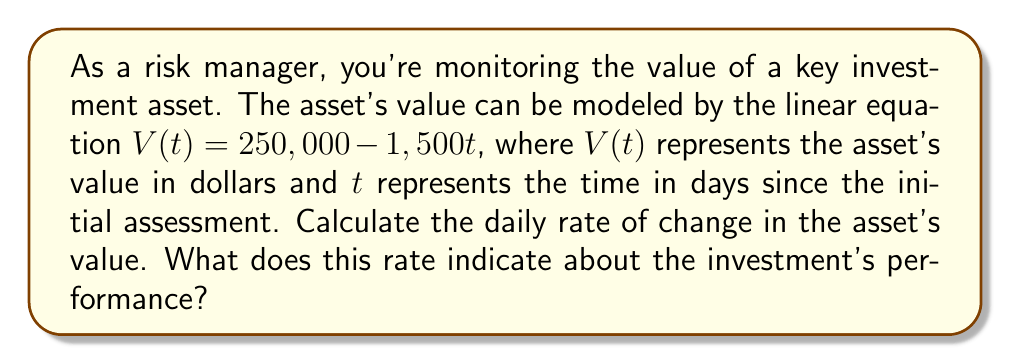Can you answer this question? To solve this problem, we need to understand the concept of rate of change in a linear equation.

1) The general form of a linear equation is $y = mx + b$, where $m$ represents the slope or rate of change.

2) In our case, we have $V(t) = 250,000 - 1,500t$

3) Comparing this to the general form, we can see that:
   $m = -1,500$
   $b = 250,000$

4) The slope $m$ represents the rate of change of $V$ with respect to $t$. In this context, it's the daily rate of change in the asset's value.

5) The negative sign indicates that the value is decreasing over time.

6) Therefore, the daily rate of change is -$1,500 per day.

This rate indicates that the investment is losing value at a constant rate of $1,500 per day. As a risk manager, this information suggests that the asset is depreciating steadily, which could be a cause for concern depending on the investment strategy and time horizon.
Answer: The daily rate of change in the asset's value is -$1,500 per day. 